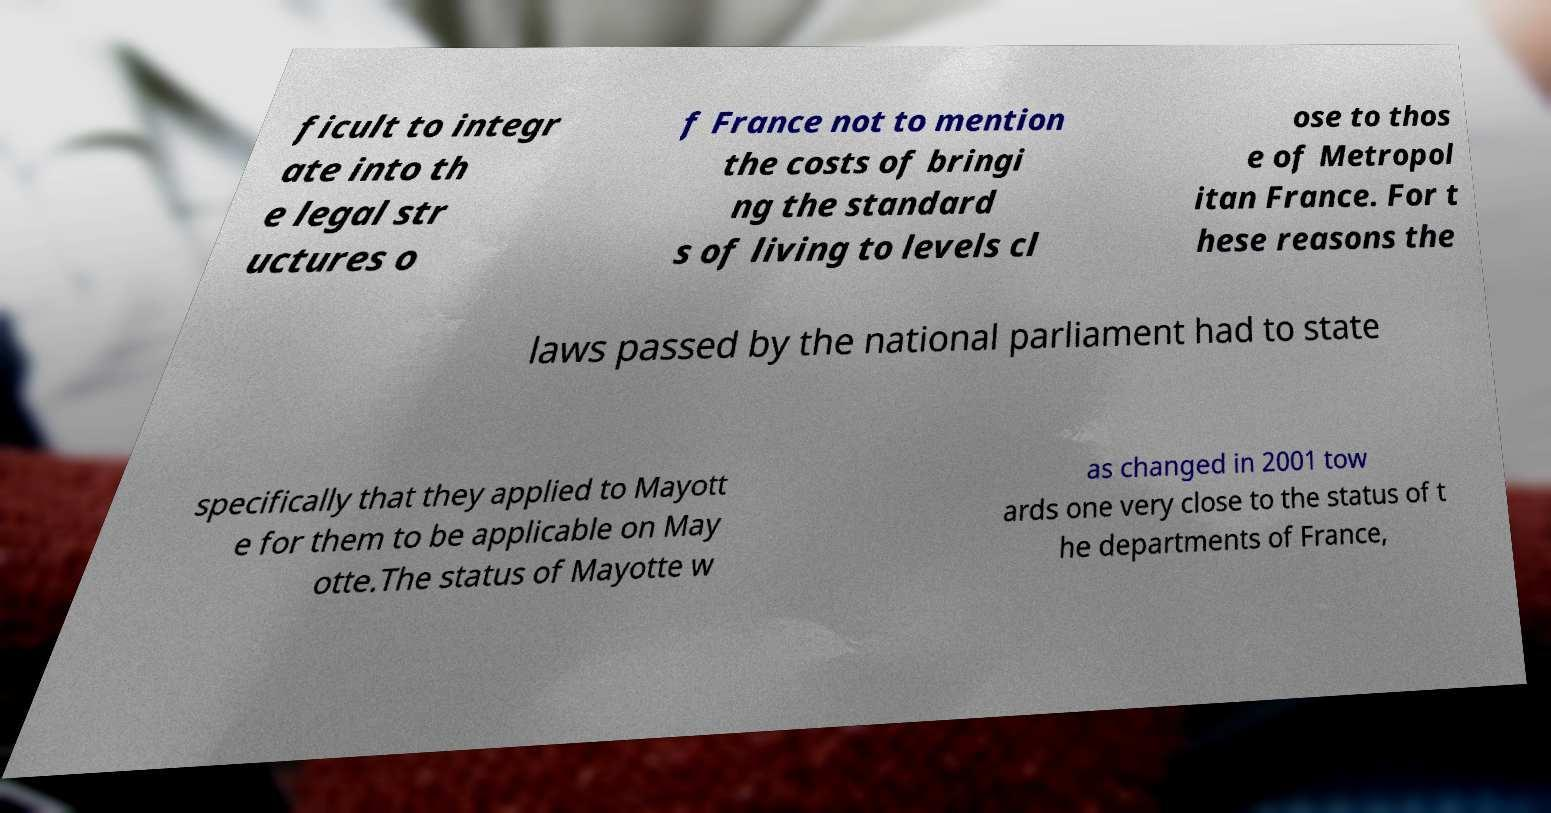Can you read and provide the text displayed in the image?This photo seems to have some interesting text. Can you extract and type it out for me? ficult to integr ate into th e legal str uctures o f France not to mention the costs of bringi ng the standard s of living to levels cl ose to thos e of Metropol itan France. For t hese reasons the laws passed by the national parliament had to state specifically that they applied to Mayott e for them to be applicable on May otte.The status of Mayotte w as changed in 2001 tow ards one very close to the status of t he departments of France, 